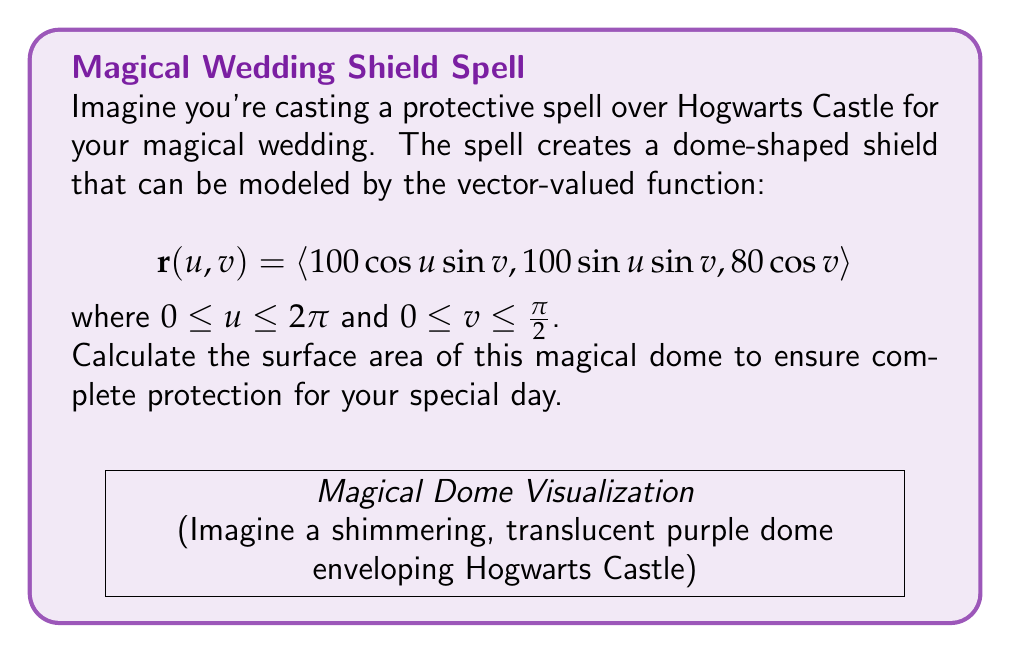Could you help me with this problem? Let's approach this step-by-step:

1) For a surface defined by $\mathbf{r}(u,v)$, the surface area is given by the double integral:

   $$SA = \iint_S \left\|\frac{\partial \mathbf{r}}{\partial u} \times \frac{\partial \mathbf{r}}{\partial v}\right\| \, du \, dv$$

2) First, let's calculate $\frac{\partial \mathbf{r}}{\partial u}$ and $\frac{\partial \mathbf{r}}{\partial v}$:

   $$\frac{\partial \mathbf{r}}{\partial u} = \langle -100\sin u \sin v, 100\cos u \sin v, 0 \rangle$$
   $$\frac{\partial \mathbf{r}}{\partial v} = \langle 100\cos u \cos v, 100\sin u \cos v, -80\sin v \rangle$$

3) Now, let's compute their cross product:

   $$\frac{\partial \mathbf{r}}{\partial u} \times \frac{\partial \mathbf{r}}{\partial v} = \langle 8000\cos u \sin^2 v, 8000\sin u \sin^2 v, 10000\sin v \cos v \rangle$$

4) The magnitude of this cross product is:

   $$\left\|\frac{\partial \mathbf{r}}{\partial u} \times \frac{\partial \mathbf{r}}{\partial v}\right\| = \sqrt{64000000\sin^4 v + 100000000\sin^2 v \cos^2 v}$$
   $$= 8000\sin v \sqrt{100 - 36\sin^2 v}$$

5) Now we can set up our double integral:

   $$SA = \int_0^{2\pi} \int_0^{\pi/2} 8000\sin v \sqrt{100 - 36\sin^2 v} \, dv \, du$$

6) The inner integral doesn't depend on $u$, so we can simplify:

   $$SA = 2\pi \int_0^{\pi/2} 8000\sin v \sqrt{100 - 36\sin^2 v} \, dv$$

7) This integral is quite complex. We can solve it using the substitution $w = \sin v$, which gives us:

   $$SA = 2\pi \cdot 8000 \int_0^1 \sqrt{100 - 36w^2} \, dw$$

8) This integral evaluates to:

   $$SA = 2\pi \cdot 8000 \cdot \frac{50}{3} \left(w\sqrt{100-36w^2} + \frac{50}{6}\arcsin\left(\frac{6w}{10}\right)\right)\bigg|_0^1$$

9) Evaluating at the limits and simplifying:

   $$SA = 2\pi \cdot 8000 \cdot \frac{50}{3} \left(\frac{8}{10} + \frac{25\pi}{36}\right) = 40000\pi\left(\frac{4}{3} + \frac{25\pi}{54}\right)$$
Answer: $$40000\pi\left(\frac{4}{3} + \frac{25\pi}{54}\right)$$ square units 